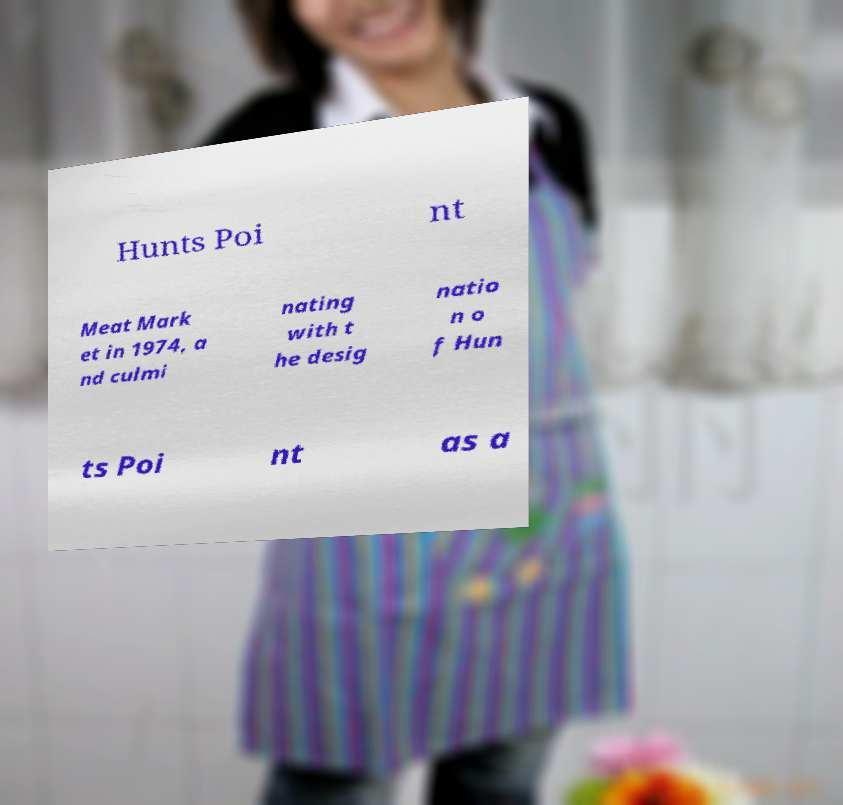There's text embedded in this image that I need extracted. Can you transcribe it verbatim? Hunts Poi nt Meat Mark et in 1974, a nd culmi nating with t he desig natio n o f Hun ts Poi nt as a 